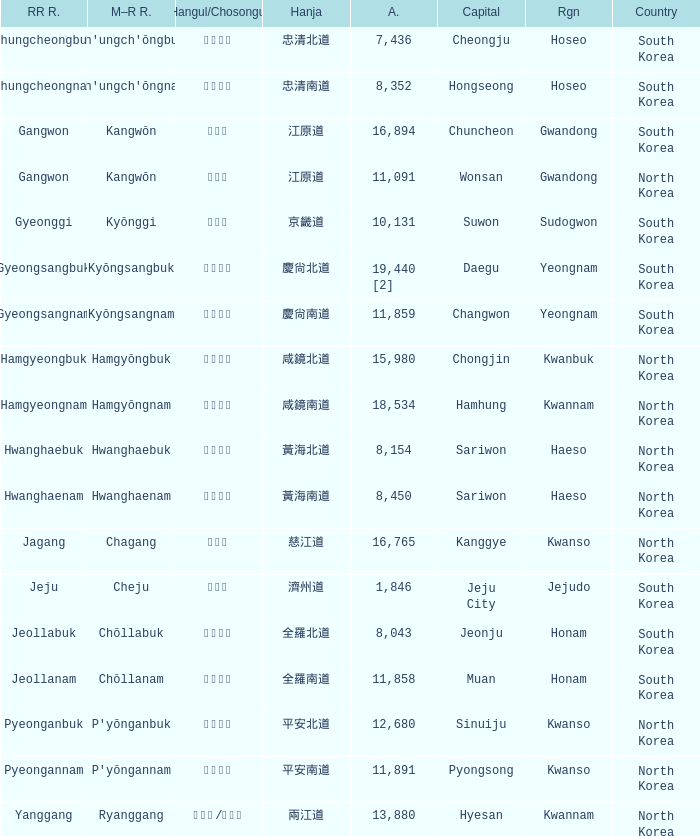Parse the full table. {'header': ['RR R.', 'M–R R.', 'Hangul/Chosongul', 'Hanja', 'A.', 'Capital', 'Rgn', 'Country'], 'rows': [['Chungcheongbuk', "Ch'ungch'ŏngbuk", '충청북도', '忠清北道', '7,436', 'Cheongju', 'Hoseo', 'South Korea'], ['Chungcheongnam', "Ch'ungch'ŏngnam", '충청남도', '忠清南道', '8,352', 'Hongseong', 'Hoseo', 'South Korea'], ['Gangwon', 'Kangwŏn', '강원도', '江原道', '16,894', 'Chuncheon', 'Gwandong', 'South Korea'], ['Gangwon', 'Kangwŏn', '강원도', '江原道', '11,091', 'Wonsan', 'Gwandong', 'North Korea'], ['Gyeonggi', 'Kyŏnggi', '경기도', '京畿道', '10,131', 'Suwon', 'Sudogwon', 'South Korea'], ['Gyeongsangbuk', 'Kyŏngsangbuk', '경상북도', '慶尙北道', '19,440 [2]', 'Daegu', 'Yeongnam', 'South Korea'], ['Gyeongsangnam', 'Kyŏngsangnam', '경상남도', '慶尙南道', '11,859', 'Changwon', 'Yeongnam', 'South Korea'], ['Hamgyeongbuk', 'Hamgyŏngbuk', '함경북도', '咸鏡北道', '15,980', 'Chongjin', 'Kwanbuk', 'North Korea'], ['Hamgyeongnam', 'Hamgyŏngnam', '함경남도', '咸鏡南道', '18,534', 'Hamhung', 'Kwannam', 'North Korea'], ['Hwanghaebuk', 'Hwanghaebuk', '황해북도', '黃海北道', '8,154', 'Sariwon', 'Haeso', 'North Korea'], ['Hwanghaenam', 'Hwanghaenam', '황해남도', '黃海南道', '8,450', 'Sariwon', 'Haeso', 'North Korea'], ['Jagang', 'Chagang', '자강도', '慈江道', '16,765', 'Kanggye', 'Kwanso', 'North Korea'], ['Jeju', 'Cheju', '제주도', '濟州道', '1,846', 'Jeju City', 'Jejudo', 'South Korea'], ['Jeollabuk', 'Chŏllabuk', '전라북도', '全羅北道', '8,043', 'Jeonju', 'Honam', 'South Korea'], ['Jeollanam', 'Chŏllanam', '전라남도', '全羅南道', '11,858', 'Muan', 'Honam', 'South Korea'], ['Pyeonganbuk', "P'yŏnganbuk", '평안북도', '平安北道', '12,680', 'Sinuiju', 'Kwanso', 'North Korea'], ['Pyeongannam', "P'yŏngannam", '평안남도', '平安南道', '11,891', 'Pyongsong', 'Kwanso', 'North Korea'], ['Yanggang', 'Ryanggang', '량강도/양강도', '兩江道', '13,880', 'Hyesan', 'Kwannam', 'North Korea']]} What is the RR Romaja for the province that has Hangul of 강원도 and capital of Wonsan? Gangwon. 